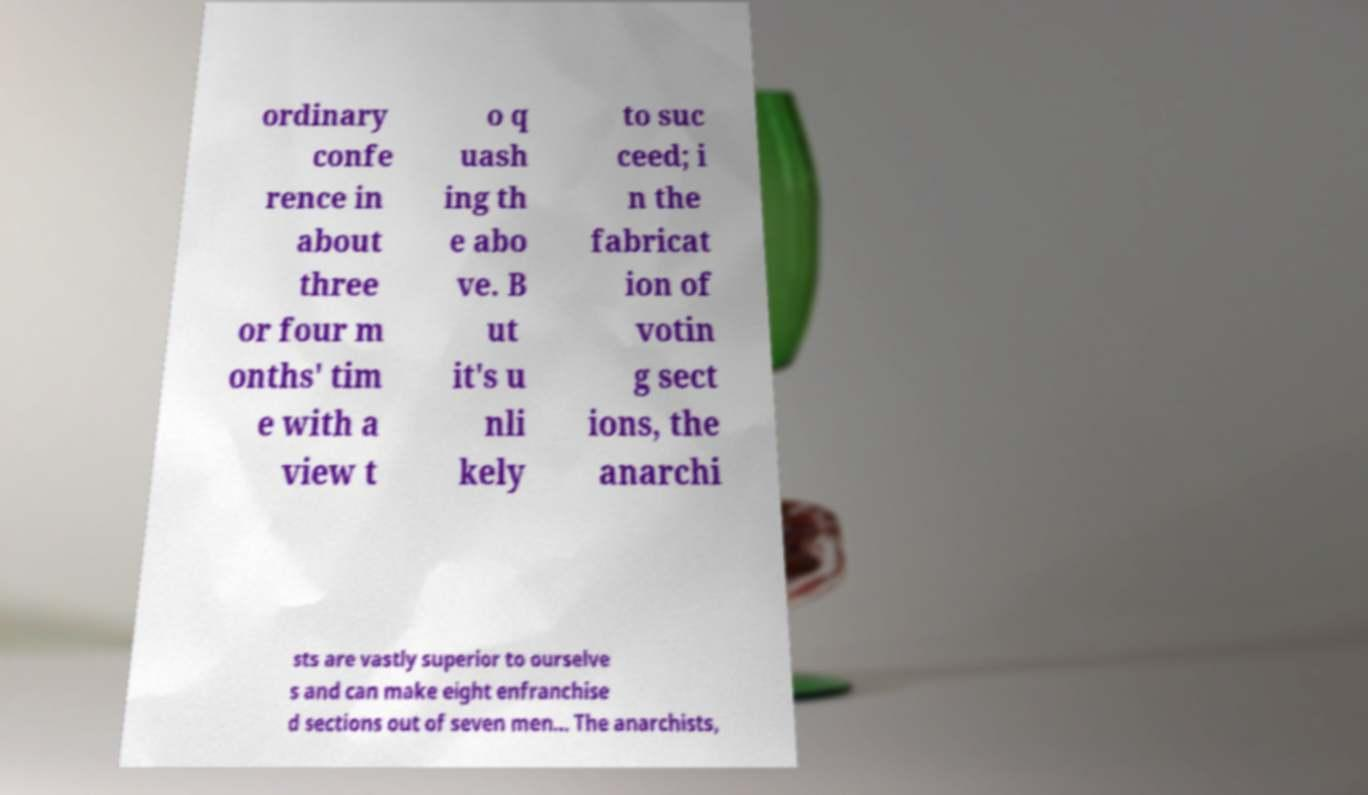Can you accurately transcribe the text from the provided image for me? ordinary confe rence in about three or four m onths' tim e with a view t o q uash ing th e abo ve. B ut it's u nli kely to suc ceed; i n the fabricat ion of votin g sect ions, the anarchi sts are vastly superior to ourselve s and can make eight enfranchise d sections out of seven men... The anarchists, 